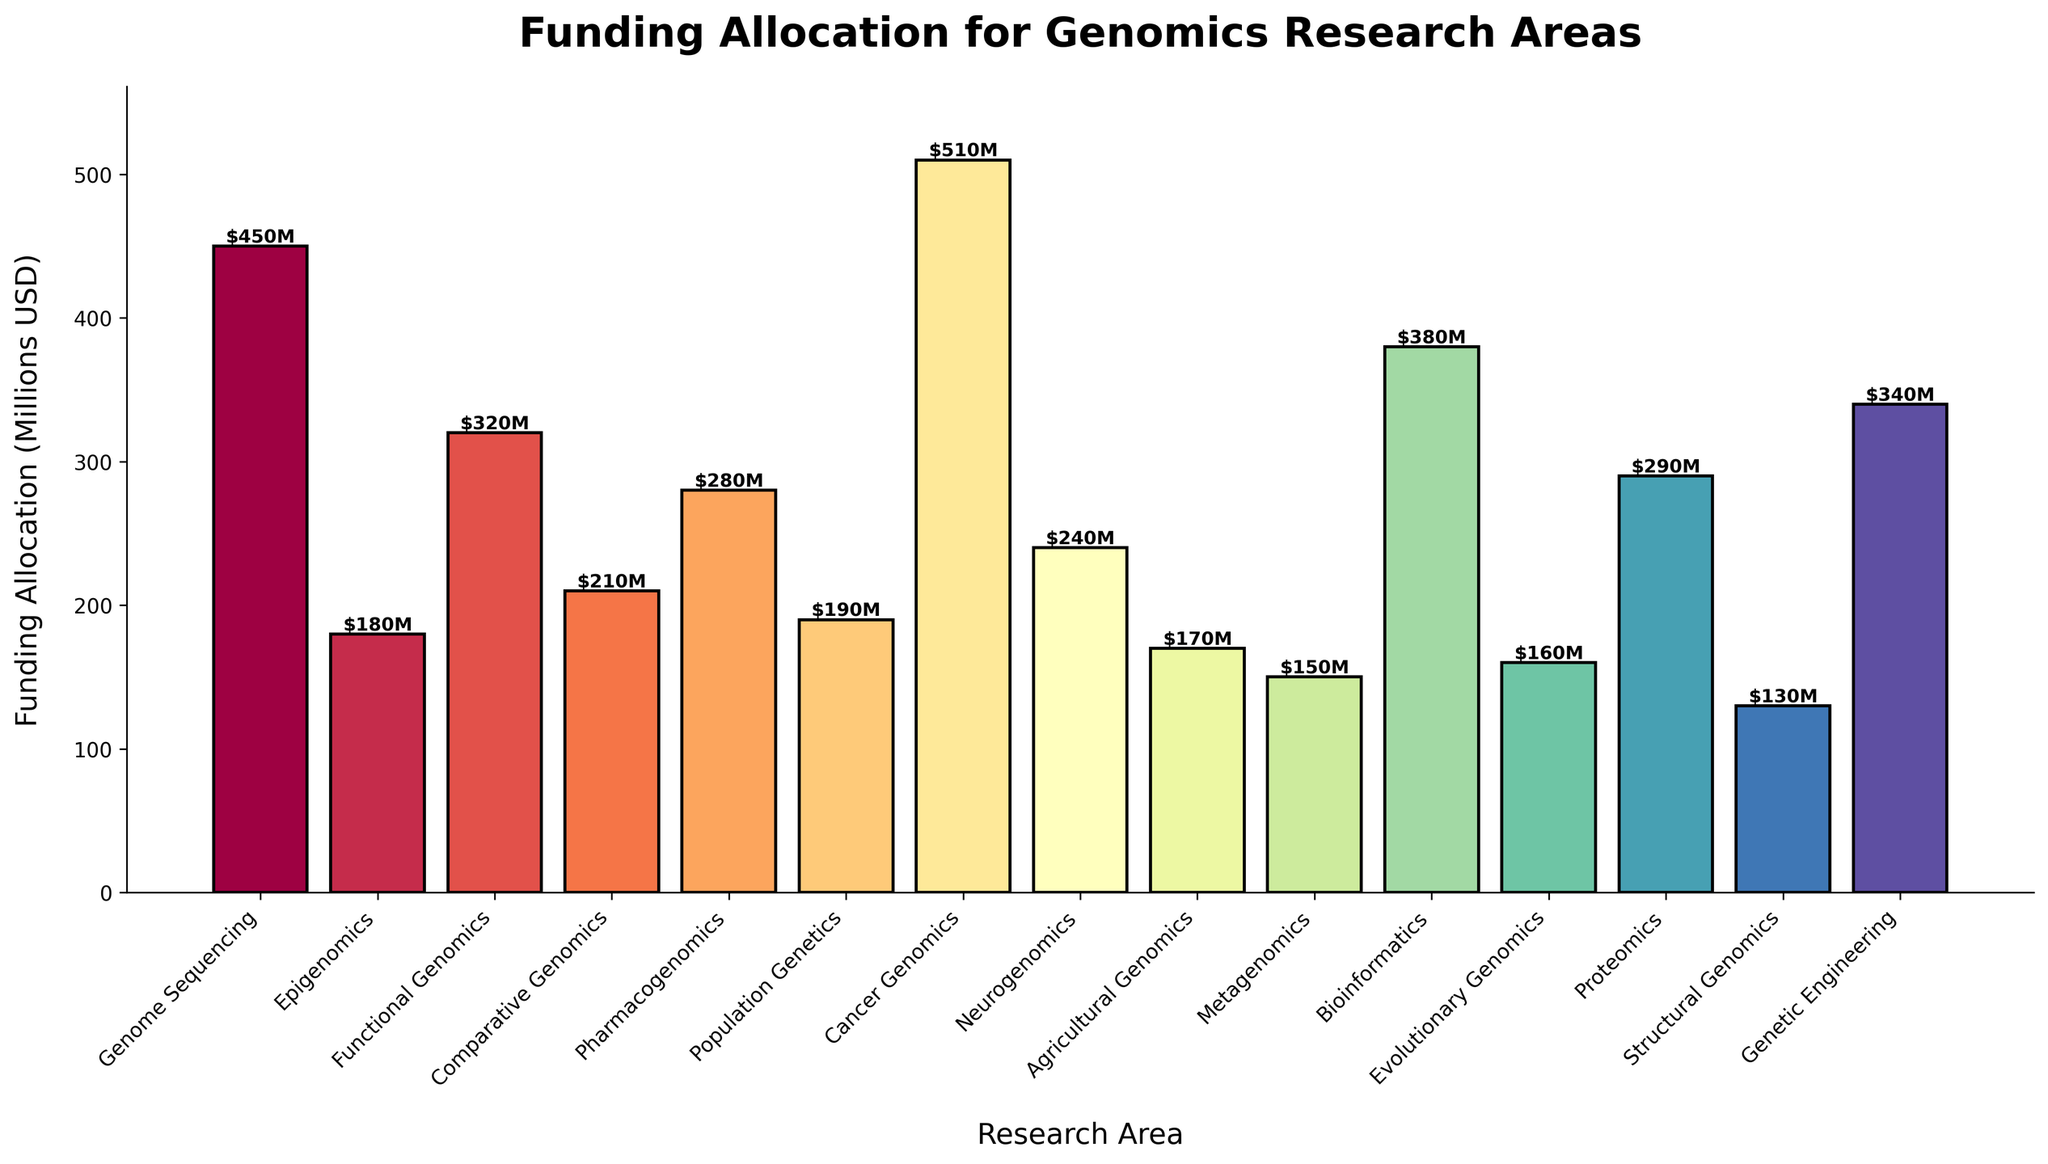Which research area has the highest funding allocation? Identify the tallest bar on the chart. The title of the research area associated with this bar represents the one with the highest funding allocation.
Answer: Cancer Genomics Which research area has the lowest funding allocation? Identify the shortest bar on the chart. The title of the research area associated with this bar represents the one with the lowest funding allocation.
Answer: Structural Genomics Is the funding allocation for Cancer Genomics more than double that of Metagenomics? Compare the height of the bar for Cancer Genomics with twice the height of the bar for Metagenomics. $510M is more than double $150M (i.e., $300M)
Answer: Yes How does the funding for Bioinformatics compare to that of Genetic Engineering? Compare the heights of the bars representing Bioinformatics and Genetic Engineering. Bioinformatics ($380M) has less funding than Genetic Engineering ($340M).
Answer: Bioinformatics has less funding Which research areas receive funding between $200M and $300M? Identify the bars whose heights indicate funding between $200 million and $300 million. These are Pharmacogenomics, Population Genetics, Neurogenomics, and Proteomics.
Answer: Pharmacogenomics, Population Genetics, Neurogenomics, Proteomics What is the combined funding allocation for Genome Sequencing, Cancer Genomics, and Bioinformatics? Add the numerical values of the funding allocations for Genome Sequencing ($450M), Cancer Genomics ($510M), and Bioinformatics ($380M). $450M + $510M + $380M = $1,340M.
Answer: $1,340M What is the average funding allocation for Comparative Genomics, Neurogenomics, and Agricultural Genomics? Add the numerical values of the funding allocations and then divide by the number of areas (3). ($210M + $240M + $170M) / 3 = $620M / 3 = $206.67M.
Answer: $206.67M Which research area has a funding allocation closer to the average funding allocation of all areas combined? Sum all funding allocations and divide by the number of research areas to get the average, then compare each individual area to this average. Total funding is $4,500M; average = $4,500M / 15 = $300M. Proteomics with $290M is closest to $300M.
Answer: Proteomics 